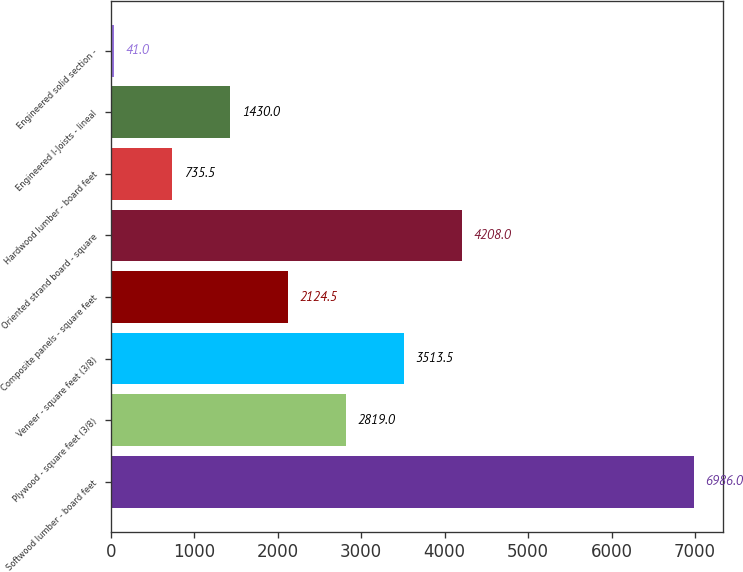Convert chart. <chart><loc_0><loc_0><loc_500><loc_500><bar_chart><fcel>Softwood lumber - board feet<fcel>Plywood - square feet (3/8)<fcel>Veneer - square feet (3/8)<fcel>Composite panels - square feet<fcel>Oriented strand board - square<fcel>Hardwood lumber - board feet<fcel>Engineered I-Joists - lineal<fcel>Engineered solid section -<nl><fcel>6986<fcel>2819<fcel>3513.5<fcel>2124.5<fcel>4208<fcel>735.5<fcel>1430<fcel>41<nl></chart> 